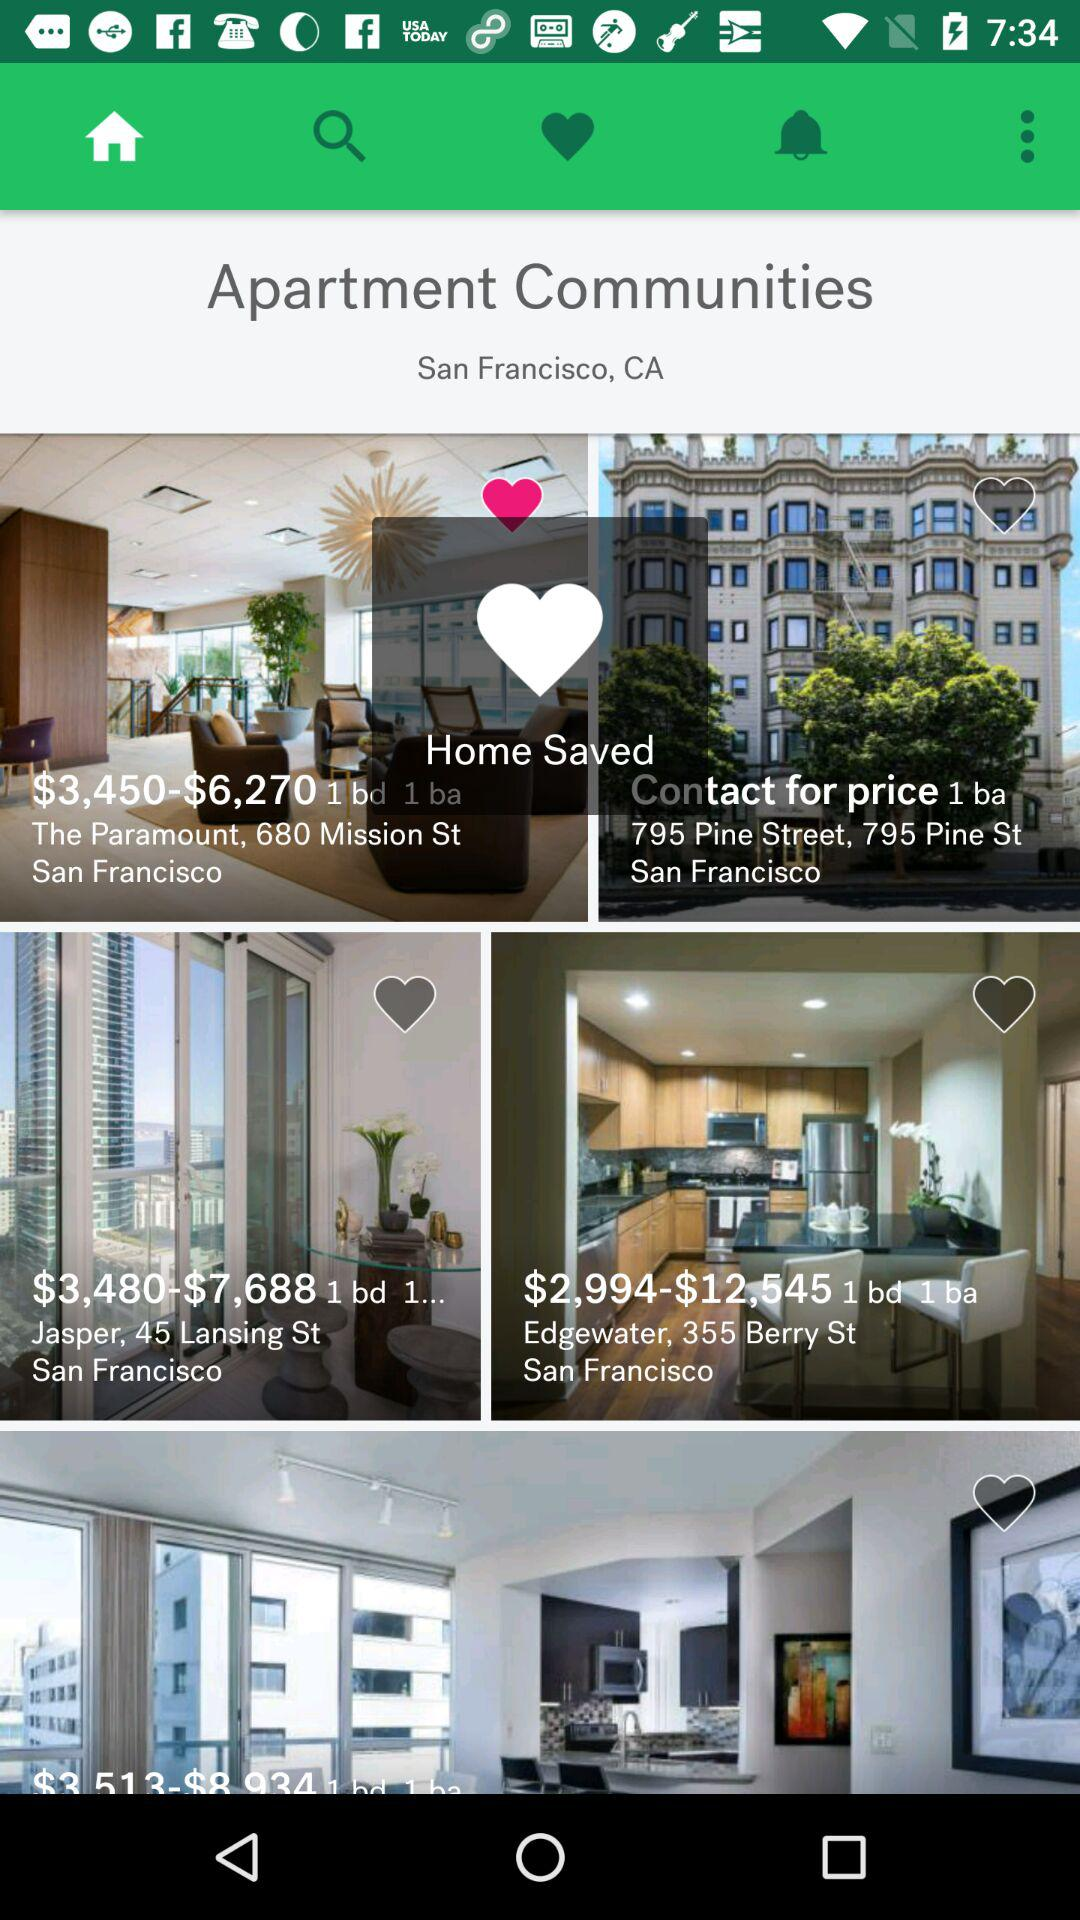What tab am I on? You are on the "Home" tab. 